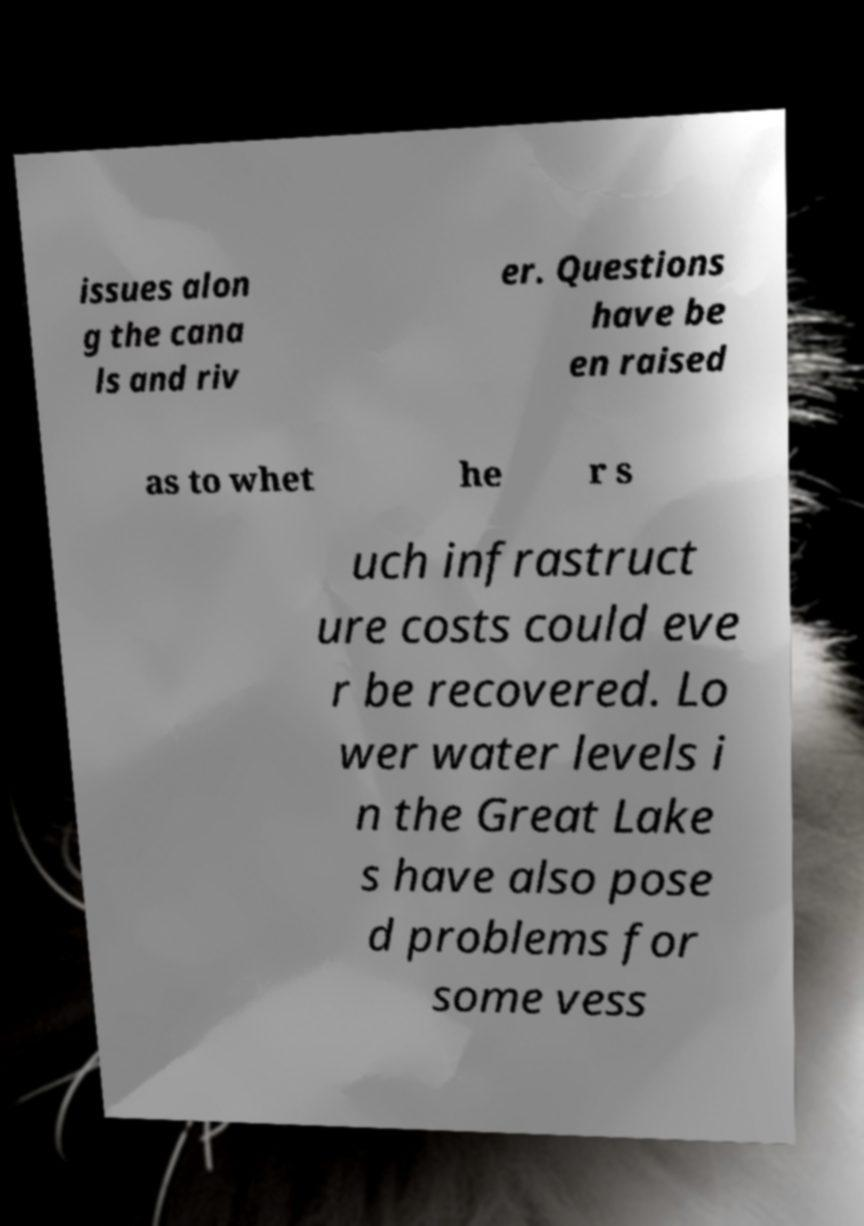Can you accurately transcribe the text from the provided image for me? issues alon g the cana ls and riv er. Questions have be en raised as to whet he r s uch infrastruct ure costs could eve r be recovered. Lo wer water levels i n the Great Lake s have also pose d problems for some vess 